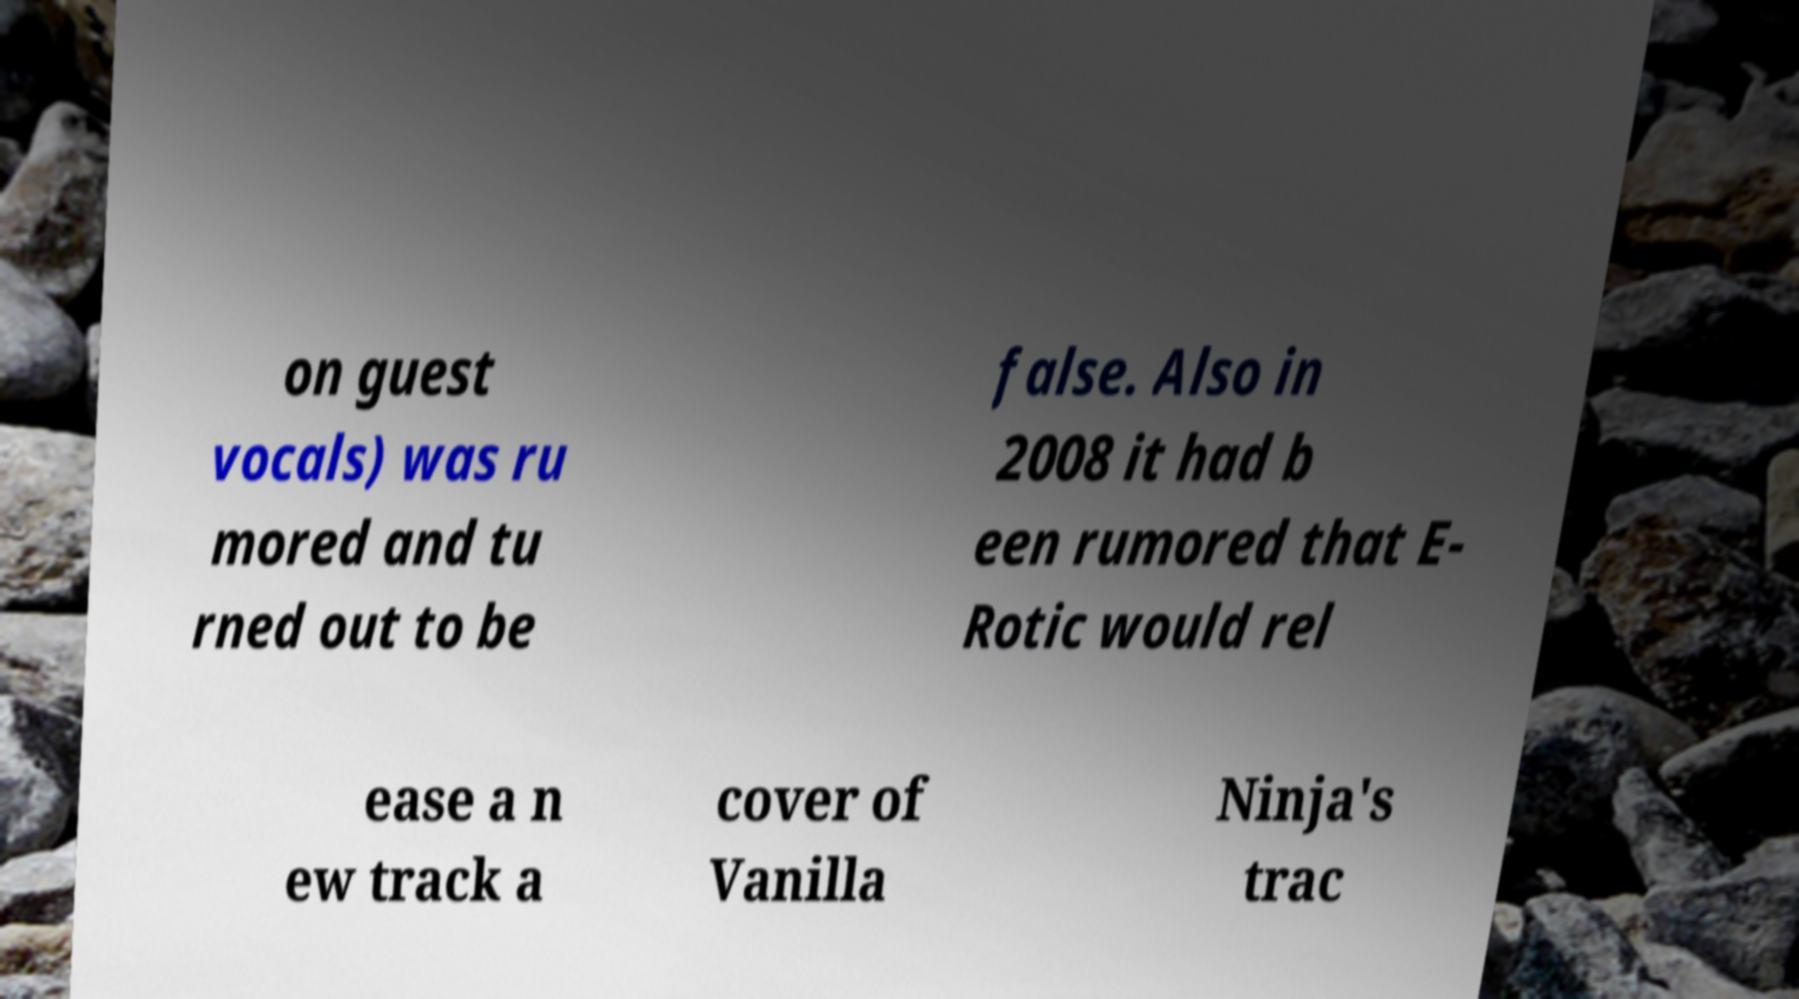What messages or text are displayed in this image? I need them in a readable, typed format. on guest vocals) was ru mored and tu rned out to be false. Also in 2008 it had b een rumored that E- Rotic would rel ease a n ew track a cover of Vanilla Ninja's trac 